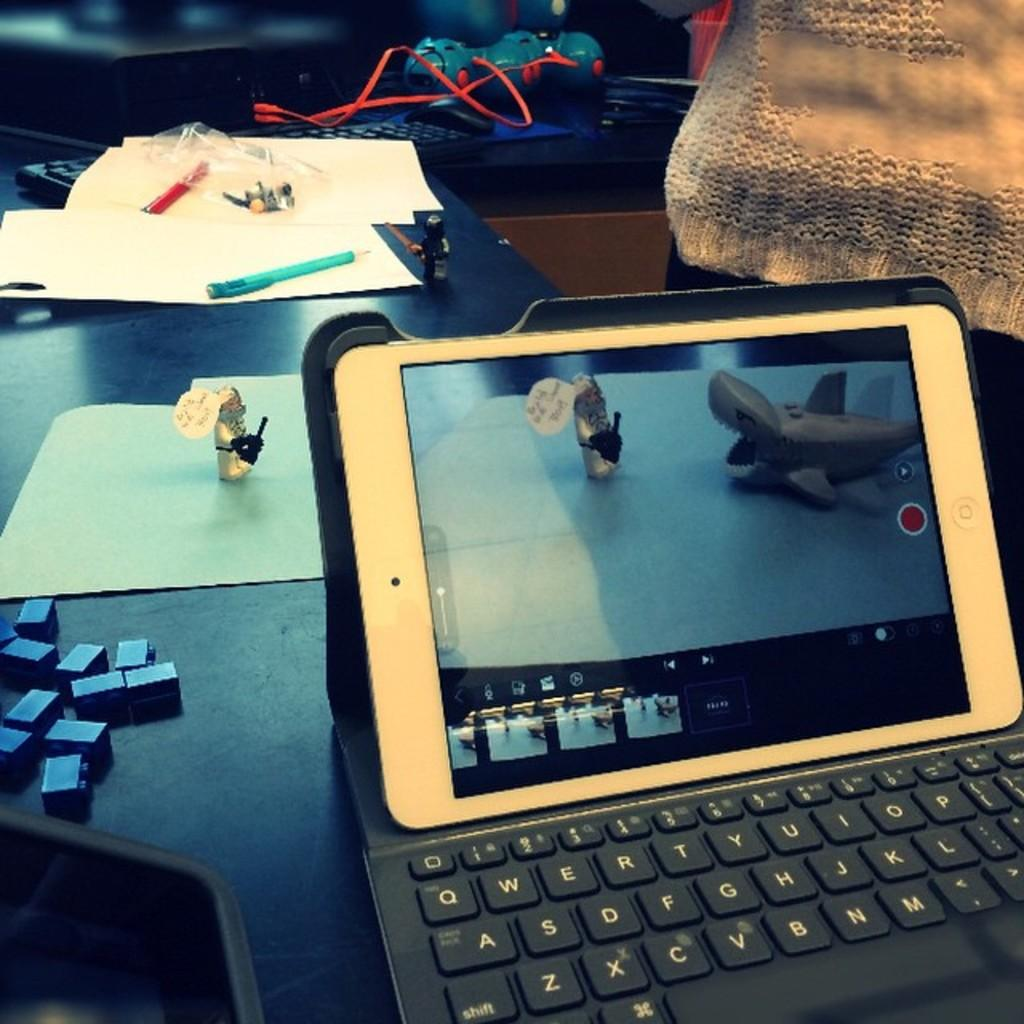What electronic device is on the table in the image? There is a laptop on the table. What other items can be seen on the table besides the laptop? There are toys, papers, a pen, and a keyboard on the table. What might be used for writing on the papers? There is a pen on the table, which can be used for writing. What type of input device is on the table? There is a keyboard on the table, which is an input device for a computer. How is the laptop being used for transportation in the image? The laptop is not being used for transportation in the image; it is stationary on the table. What type of weightlifting equipment is present on the table in the image? There is no weightlifting equipment present on the table in the image. 